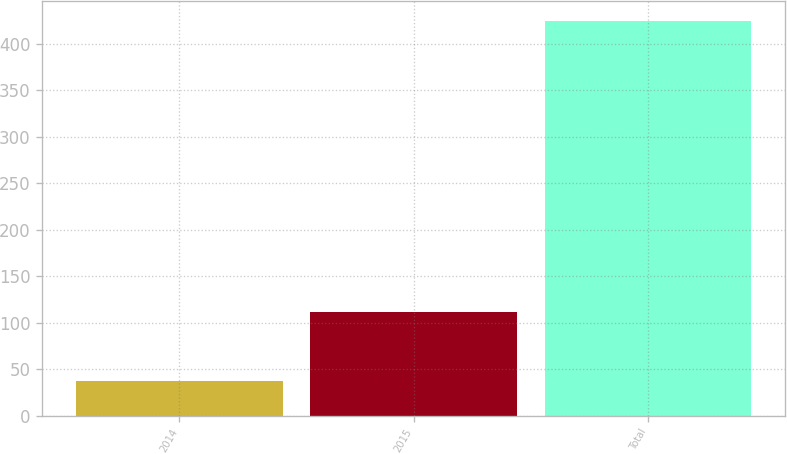Convert chart to OTSL. <chart><loc_0><loc_0><loc_500><loc_500><bar_chart><fcel>2014<fcel>2015<fcel>Total<nl><fcel>37<fcel>112<fcel>425<nl></chart> 